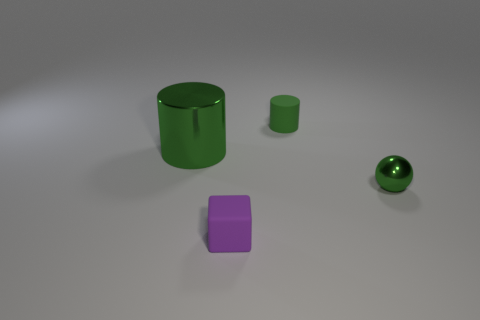Add 1 large gray metallic cylinders. How many objects exist? 5 Subtract 1 cylinders. How many cylinders are left? 1 Subtract 0 purple cylinders. How many objects are left? 4 Subtract all balls. How many objects are left? 3 Subtract all brown cylinders. Subtract all brown cubes. How many cylinders are left? 2 Subtract all green blocks. How many cyan cylinders are left? 0 Subtract all tiny shiny things. Subtract all big purple shiny cubes. How many objects are left? 3 Add 4 large green metal things. How many large green metal things are left? 5 Add 2 large yellow metallic blocks. How many large yellow metallic blocks exist? 2 